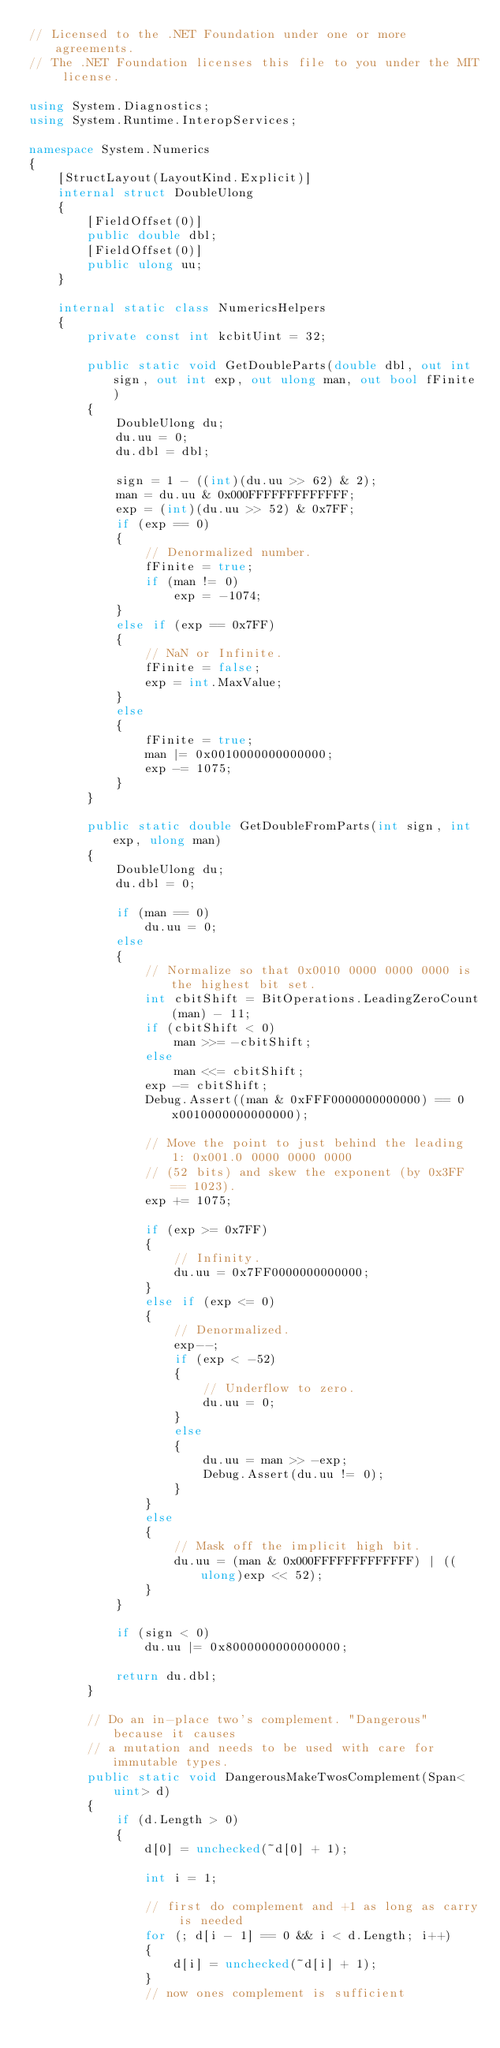<code> <loc_0><loc_0><loc_500><loc_500><_C#_>// Licensed to the .NET Foundation under one or more agreements.
// The .NET Foundation licenses this file to you under the MIT license.

using System.Diagnostics;
using System.Runtime.InteropServices;

namespace System.Numerics
{
    [StructLayout(LayoutKind.Explicit)]
    internal struct DoubleUlong
    {
        [FieldOffset(0)]
        public double dbl;
        [FieldOffset(0)]
        public ulong uu;
    }

    internal static class NumericsHelpers
    {
        private const int kcbitUint = 32;

        public static void GetDoubleParts(double dbl, out int sign, out int exp, out ulong man, out bool fFinite)
        {
            DoubleUlong du;
            du.uu = 0;
            du.dbl = dbl;

            sign = 1 - ((int)(du.uu >> 62) & 2);
            man = du.uu & 0x000FFFFFFFFFFFFF;
            exp = (int)(du.uu >> 52) & 0x7FF;
            if (exp == 0)
            {
                // Denormalized number.
                fFinite = true;
                if (man != 0)
                    exp = -1074;
            }
            else if (exp == 0x7FF)
            {
                // NaN or Infinite.
                fFinite = false;
                exp = int.MaxValue;
            }
            else
            {
                fFinite = true;
                man |= 0x0010000000000000;
                exp -= 1075;
            }
        }

        public static double GetDoubleFromParts(int sign, int exp, ulong man)
        {
            DoubleUlong du;
            du.dbl = 0;

            if (man == 0)
                du.uu = 0;
            else
            {
                // Normalize so that 0x0010 0000 0000 0000 is the highest bit set.
                int cbitShift = BitOperations.LeadingZeroCount(man) - 11;
                if (cbitShift < 0)
                    man >>= -cbitShift;
                else
                    man <<= cbitShift;
                exp -= cbitShift;
                Debug.Assert((man & 0xFFF0000000000000) == 0x0010000000000000);

                // Move the point to just behind the leading 1: 0x001.0 0000 0000 0000
                // (52 bits) and skew the exponent (by 0x3FF == 1023).
                exp += 1075;

                if (exp >= 0x7FF)
                {
                    // Infinity.
                    du.uu = 0x7FF0000000000000;
                }
                else if (exp <= 0)
                {
                    // Denormalized.
                    exp--;
                    if (exp < -52)
                    {
                        // Underflow to zero.
                        du.uu = 0;
                    }
                    else
                    {
                        du.uu = man >> -exp;
                        Debug.Assert(du.uu != 0);
                    }
                }
                else
                {
                    // Mask off the implicit high bit.
                    du.uu = (man & 0x000FFFFFFFFFFFFF) | ((ulong)exp << 52);
                }
            }

            if (sign < 0)
                du.uu |= 0x8000000000000000;

            return du.dbl;
        }

        // Do an in-place two's complement. "Dangerous" because it causes
        // a mutation and needs to be used with care for immutable types.
        public static void DangerousMakeTwosComplement(Span<uint> d)
        {
            if (d.Length > 0)
            {
                d[0] = unchecked(~d[0] + 1);

                int i = 1;

                // first do complement and +1 as long as carry is needed
                for (; d[i - 1] == 0 && i < d.Length; i++)
                {
                    d[i] = unchecked(~d[i] + 1);
                }
                // now ones complement is sufficient</code> 